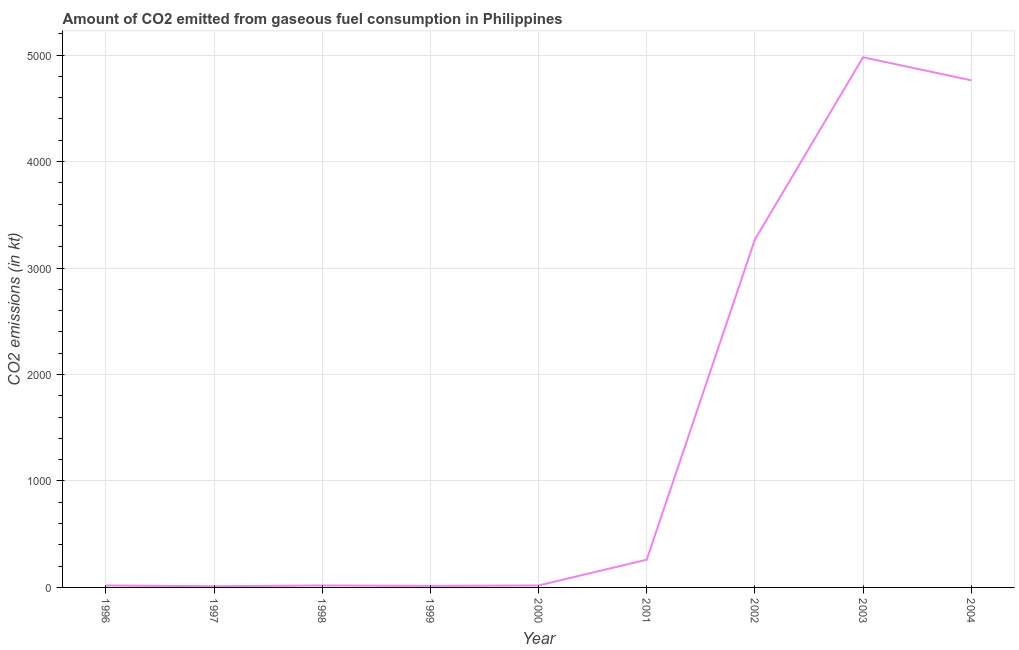What is the co2 emissions from gaseous fuel consumption in 2004?
Make the answer very short. 4763.43. Across all years, what is the maximum co2 emissions from gaseous fuel consumption?
Your response must be concise. 4979.79. Across all years, what is the minimum co2 emissions from gaseous fuel consumption?
Offer a terse response. 11. In which year was the co2 emissions from gaseous fuel consumption minimum?
Offer a terse response. 1997. What is the sum of the co2 emissions from gaseous fuel consumption?
Offer a terse response. 1.34e+04. What is the difference between the co2 emissions from gaseous fuel consumption in 1997 and 1998?
Provide a succinct answer. -7.33. What is the average co2 emissions from gaseous fuel consumption per year?
Give a very brief answer. 1483.51. What is the median co2 emissions from gaseous fuel consumption?
Offer a very short reply. 18.34. In how many years, is the co2 emissions from gaseous fuel consumption greater than 400 kt?
Offer a terse response. 3. What is the ratio of the co2 emissions from gaseous fuel consumption in 2000 to that in 2003?
Your answer should be very brief. 0. Is the co2 emissions from gaseous fuel consumption in 1997 less than that in 1998?
Make the answer very short. Yes. Is the difference between the co2 emissions from gaseous fuel consumption in 1996 and 2000 greater than the difference between any two years?
Make the answer very short. No. What is the difference between the highest and the second highest co2 emissions from gaseous fuel consumption?
Your answer should be compact. 216.35. What is the difference between the highest and the lowest co2 emissions from gaseous fuel consumption?
Your answer should be very brief. 4968.78. In how many years, is the co2 emissions from gaseous fuel consumption greater than the average co2 emissions from gaseous fuel consumption taken over all years?
Provide a succinct answer. 3. How many lines are there?
Make the answer very short. 1. What is the difference between two consecutive major ticks on the Y-axis?
Your response must be concise. 1000. Are the values on the major ticks of Y-axis written in scientific E-notation?
Offer a very short reply. No. Does the graph contain grids?
Offer a very short reply. Yes. What is the title of the graph?
Your answer should be compact. Amount of CO2 emitted from gaseous fuel consumption in Philippines. What is the label or title of the X-axis?
Provide a succinct answer. Year. What is the label or title of the Y-axis?
Ensure brevity in your answer.  CO2 emissions (in kt). What is the CO2 emissions (in kt) of 1996?
Your answer should be very brief. 18.34. What is the CO2 emissions (in kt) of 1997?
Make the answer very short. 11. What is the CO2 emissions (in kt) in 1998?
Provide a succinct answer. 18.34. What is the CO2 emissions (in kt) of 1999?
Your answer should be very brief. 14.67. What is the CO2 emissions (in kt) of 2000?
Offer a very short reply. 18.34. What is the CO2 emissions (in kt) of 2001?
Ensure brevity in your answer.  260.36. What is the CO2 emissions (in kt) in 2002?
Your answer should be compact. 3267.3. What is the CO2 emissions (in kt) of 2003?
Give a very brief answer. 4979.79. What is the CO2 emissions (in kt) in 2004?
Give a very brief answer. 4763.43. What is the difference between the CO2 emissions (in kt) in 1996 and 1997?
Keep it short and to the point. 7.33. What is the difference between the CO2 emissions (in kt) in 1996 and 1998?
Your answer should be very brief. 0. What is the difference between the CO2 emissions (in kt) in 1996 and 1999?
Your response must be concise. 3.67. What is the difference between the CO2 emissions (in kt) in 1996 and 2001?
Offer a very short reply. -242.02. What is the difference between the CO2 emissions (in kt) in 1996 and 2002?
Provide a short and direct response. -3248.96. What is the difference between the CO2 emissions (in kt) in 1996 and 2003?
Your response must be concise. -4961.45. What is the difference between the CO2 emissions (in kt) in 1996 and 2004?
Your response must be concise. -4745.1. What is the difference between the CO2 emissions (in kt) in 1997 and 1998?
Keep it short and to the point. -7.33. What is the difference between the CO2 emissions (in kt) in 1997 and 1999?
Provide a short and direct response. -3.67. What is the difference between the CO2 emissions (in kt) in 1997 and 2000?
Provide a short and direct response. -7.33. What is the difference between the CO2 emissions (in kt) in 1997 and 2001?
Offer a very short reply. -249.36. What is the difference between the CO2 emissions (in kt) in 1997 and 2002?
Provide a short and direct response. -3256.3. What is the difference between the CO2 emissions (in kt) in 1997 and 2003?
Your answer should be very brief. -4968.78. What is the difference between the CO2 emissions (in kt) in 1997 and 2004?
Your answer should be compact. -4752.43. What is the difference between the CO2 emissions (in kt) in 1998 and 1999?
Offer a very short reply. 3.67. What is the difference between the CO2 emissions (in kt) in 1998 and 2000?
Your answer should be compact. 0. What is the difference between the CO2 emissions (in kt) in 1998 and 2001?
Make the answer very short. -242.02. What is the difference between the CO2 emissions (in kt) in 1998 and 2002?
Offer a very short reply. -3248.96. What is the difference between the CO2 emissions (in kt) in 1998 and 2003?
Your answer should be compact. -4961.45. What is the difference between the CO2 emissions (in kt) in 1998 and 2004?
Keep it short and to the point. -4745.1. What is the difference between the CO2 emissions (in kt) in 1999 and 2000?
Make the answer very short. -3.67. What is the difference between the CO2 emissions (in kt) in 1999 and 2001?
Keep it short and to the point. -245.69. What is the difference between the CO2 emissions (in kt) in 1999 and 2002?
Offer a terse response. -3252.63. What is the difference between the CO2 emissions (in kt) in 1999 and 2003?
Your answer should be compact. -4965.12. What is the difference between the CO2 emissions (in kt) in 1999 and 2004?
Keep it short and to the point. -4748.77. What is the difference between the CO2 emissions (in kt) in 2000 and 2001?
Offer a very short reply. -242.02. What is the difference between the CO2 emissions (in kt) in 2000 and 2002?
Keep it short and to the point. -3248.96. What is the difference between the CO2 emissions (in kt) in 2000 and 2003?
Your response must be concise. -4961.45. What is the difference between the CO2 emissions (in kt) in 2000 and 2004?
Your response must be concise. -4745.1. What is the difference between the CO2 emissions (in kt) in 2001 and 2002?
Provide a succinct answer. -3006.94. What is the difference between the CO2 emissions (in kt) in 2001 and 2003?
Offer a terse response. -4719.43. What is the difference between the CO2 emissions (in kt) in 2001 and 2004?
Your answer should be compact. -4503.08. What is the difference between the CO2 emissions (in kt) in 2002 and 2003?
Keep it short and to the point. -1712.49. What is the difference between the CO2 emissions (in kt) in 2002 and 2004?
Your response must be concise. -1496.14. What is the difference between the CO2 emissions (in kt) in 2003 and 2004?
Your answer should be compact. 216.35. What is the ratio of the CO2 emissions (in kt) in 1996 to that in 1997?
Make the answer very short. 1.67. What is the ratio of the CO2 emissions (in kt) in 1996 to that in 1999?
Your answer should be very brief. 1.25. What is the ratio of the CO2 emissions (in kt) in 1996 to that in 2000?
Make the answer very short. 1. What is the ratio of the CO2 emissions (in kt) in 1996 to that in 2001?
Provide a succinct answer. 0.07. What is the ratio of the CO2 emissions (in kt) in 1996 to that in 2002?
Provide a succinct answer. 0.01. What is the ratio of the CO2 emissions (in kt) in 1996 to that in 2003?
Offer a very short reply. 0. What is the ratio of the CO2 emissions (in kt) in 1996 to that in 2004?
Your answer should be compact. 0. What is the ratio of the CO2 emissions (in kt) in 1997 to that in 1999?
Keep it short and to the point. 0.75. What is the ratio of the CO2 emissions (in kt) in 1997 to that in 2001?
Offer a very short reply. 0.04. What is the ratio of the CO2 emissions (in kt) in 1997 to that in 2002?
Your response must be concise. 0. What is the ratio of the CO2 emissions (in kt) in 1997 to that in 2003?
Make the answer very short. 0. What is the ratio of the CO2 emissions (in kt) in 1997 to that in 2004?
Your response must be concise. 0. What is the ratio of the CO2 emissions (in kt) in 1998 to that in 2000?
Give a very brief answer. 1. What is the ratio of the CO2 emissions (in kt) in 1998 to that in 2001?
Give a very brief answer. 0.07. What is the ratio of the CO2 emissions (in kt) in 1998 to that in 2002?
Offer a terse response. 0.01. What is the ratio of the CO2 emissions (in kt) in 1998 to that in 2003?
Your answer should be very brief. 0. What is the ratio of the CO2 emissions (in kt) in 1998 to that in 2004?
Your answer should be very brief. 0. What is the ratio of the CO2 emissions (in kt) in 1999 to that in 2000?
Provide a short and direct response. 0.8. What is the ratio of the CO2 emissions (in kt) in 1999 to that in 2001?
Make the answer very short. 0.06. What is the ratio of the CO2 emissions (in kt) in 1999 to that in 2002?
Provide a short and direct response. 0. What is the ratio of the CO2 emissions (in kt) in 1999 to that in 2003?
Offer a terse response. 0. What is the ratio of the CO2 emissions (in kt) in 1999 to that in 2004?
Keep it short and to the point. 0. What is the ratio of the CO2 emissions (in kt) in 2000 to that in 2001?
Your response must be concise. 0.07. What is the ratio of the CO2 emissions (in kt) in 2000 to that in 2002?
Your response must be concise. 0.01. What is the ratio of the CO2 emissions (in kt) in 2000 to that in 2003?
Ensure brevity in your answer.  0. What is the ratio of the CO2 emissions (in kt) in 2000 to that in 2004?
Your answer should be compact. 0. What is the ratio of the CO2 emissions (in kt) in 2001 to that in 2003?
Your response must be concise. 0.05. What is the ratio of the CO2 emissions (in kt) in 2001 to that in 2004?
Make the answer very short. 0.06. What is the ratio of the CO2 emissions (in kt) in 2002 to that in 2003?
Your response must be concise. 0.66. What is the ratio of the CO2 emissions (in kt) in 2002 to that in 2004?
Provide a short and direct response. 0.69. What is the ratio of the CO2 emissions (in kt) in 2003 to that in 2004?
Offer a very short reply. 1.04. 